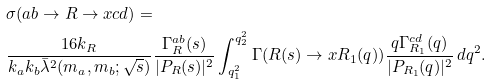<formula> <loc_0><loc_0><loc_500><loc_500>& \sigma ( a b \rightarrow R \rightarrow x c d ) = \\ & \frac { 1 6 k _ { R } } { k _ { a } k _ { b } \bar { \lambda } ^ { 2 } ( m _ { a } , m _ { b } ; \sqrt { s } ) } \frac { \Gamma ^ { a b } _ { R } ( s ) } { | P _ { R } ( s ) | ^ { 2 } } \int _ { q ^ { 2 } _ { 1 } } ^ { q ^ { 2 } _ { 2 } } \Gamma ( R ( s ) \rightarrow x R _ { 1 } ( q ) ) \frac { q \Gamma ^ { c d } _ { R _ { 1 } } ( q ) } { | P _ { R _ { 1 } } ( q ) | ^ { 2 } } \, d q ^ { 2 } .</formula> 